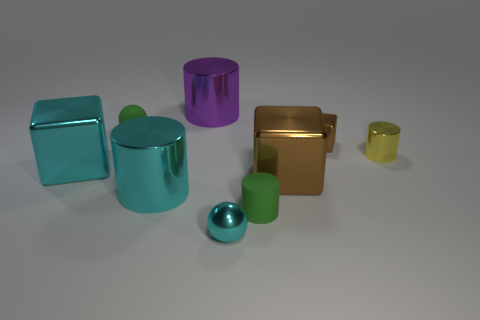Add 1 red balls. How many objects exist? 10 Subtract all cylinders. How many objects are left? 5 Subtract 0 purple blocks. How many objects are left? 9 Subtract all small yellow cylinders. Subtract all cyan metal spheres. How many objects are left? 7 Add 7 small rubber cylinders. How many small rubber cylinders are left? 8 Add 9 big cyan cubes. How many big cyan cubes exist? 10 